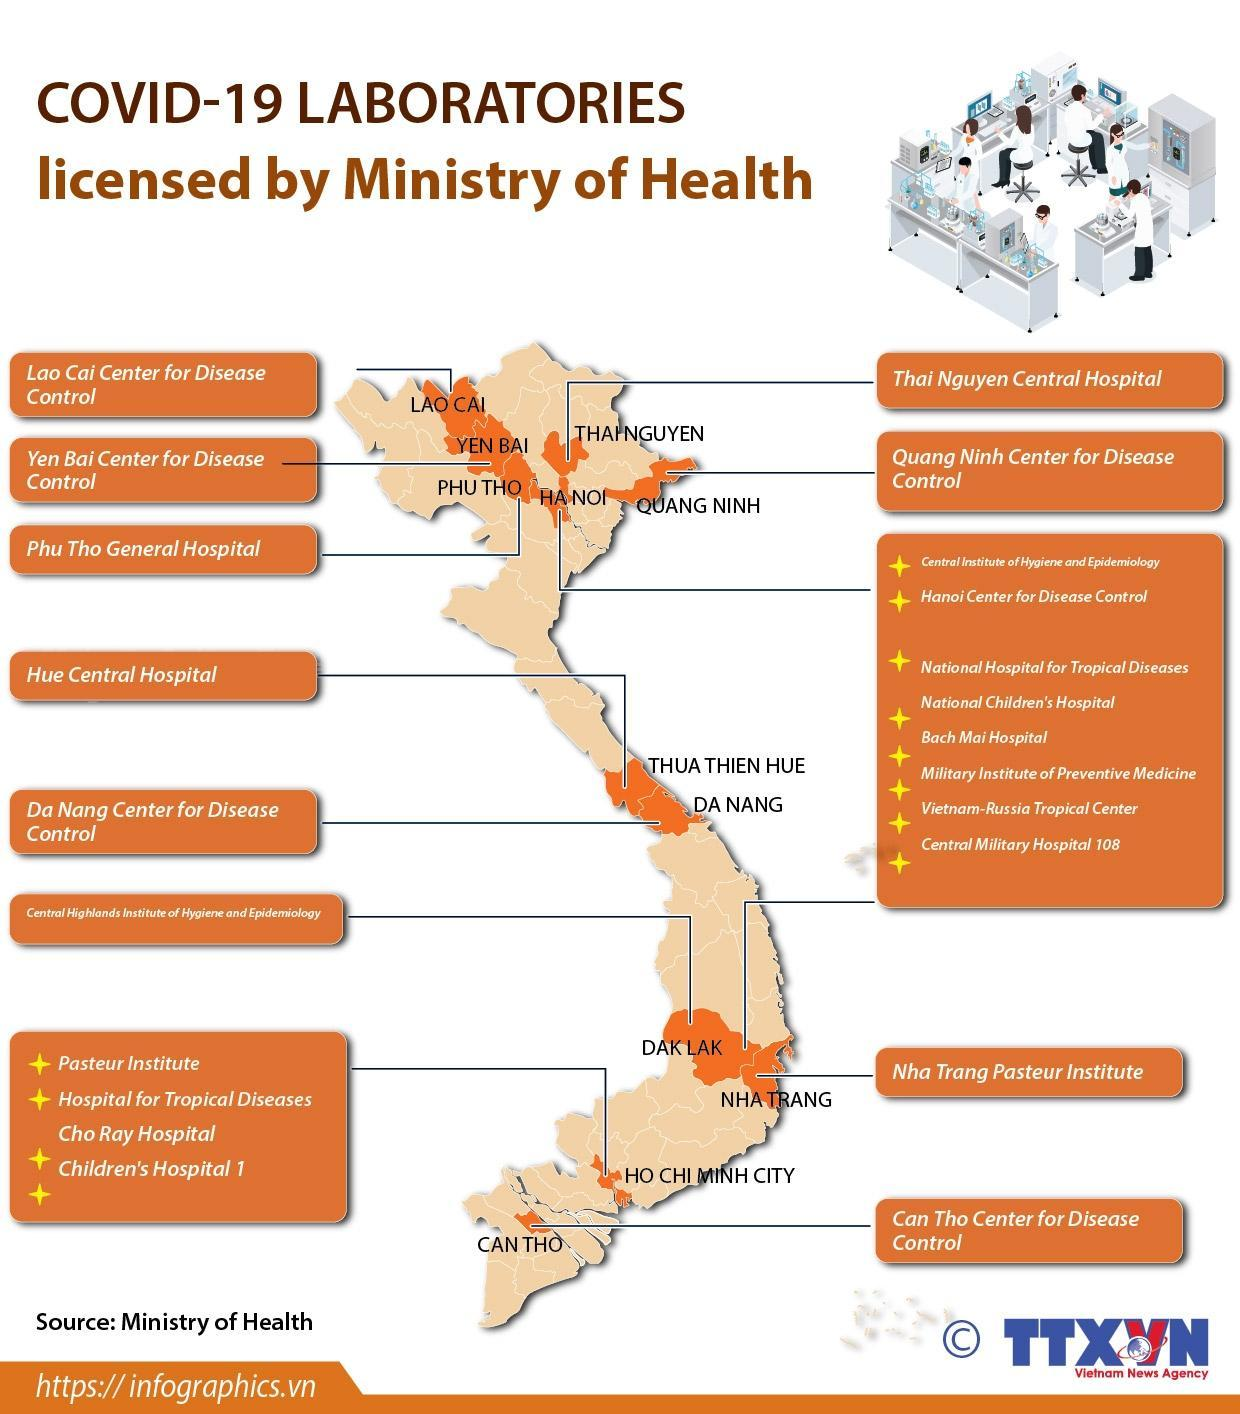How many central hospitals are in this infographic?
Answer the question with a short phrase. 2 What is the number of disease control centers in this infographic? 6 